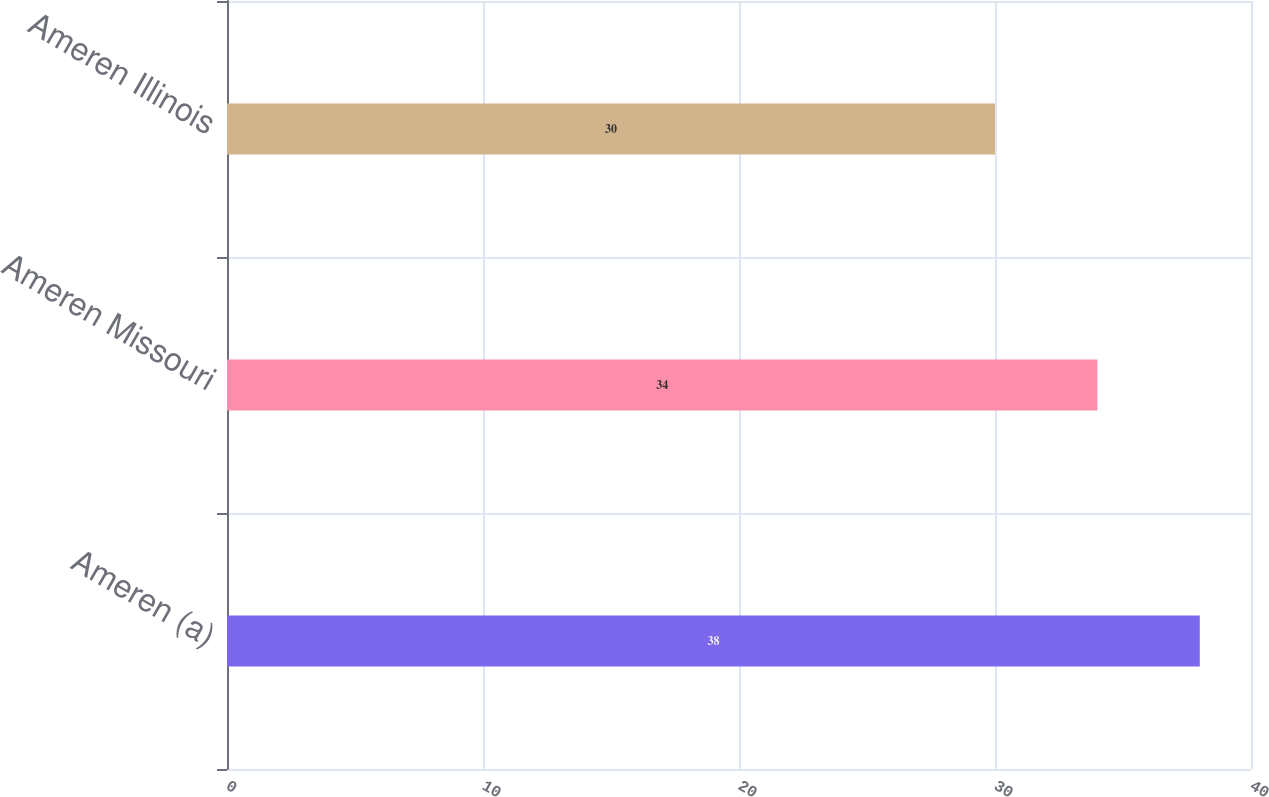<chart> <loc_0><loc_0><loc_500><loc_500><bar_chart><fcel>Ameren (a)<fcel>Ameren Missouri<fcel>Ameren Illinois<nl><fcel>38<fcel>34<fcel>30<nl></chart> 